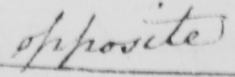Can you read and transcribe this handwriting? opposite 